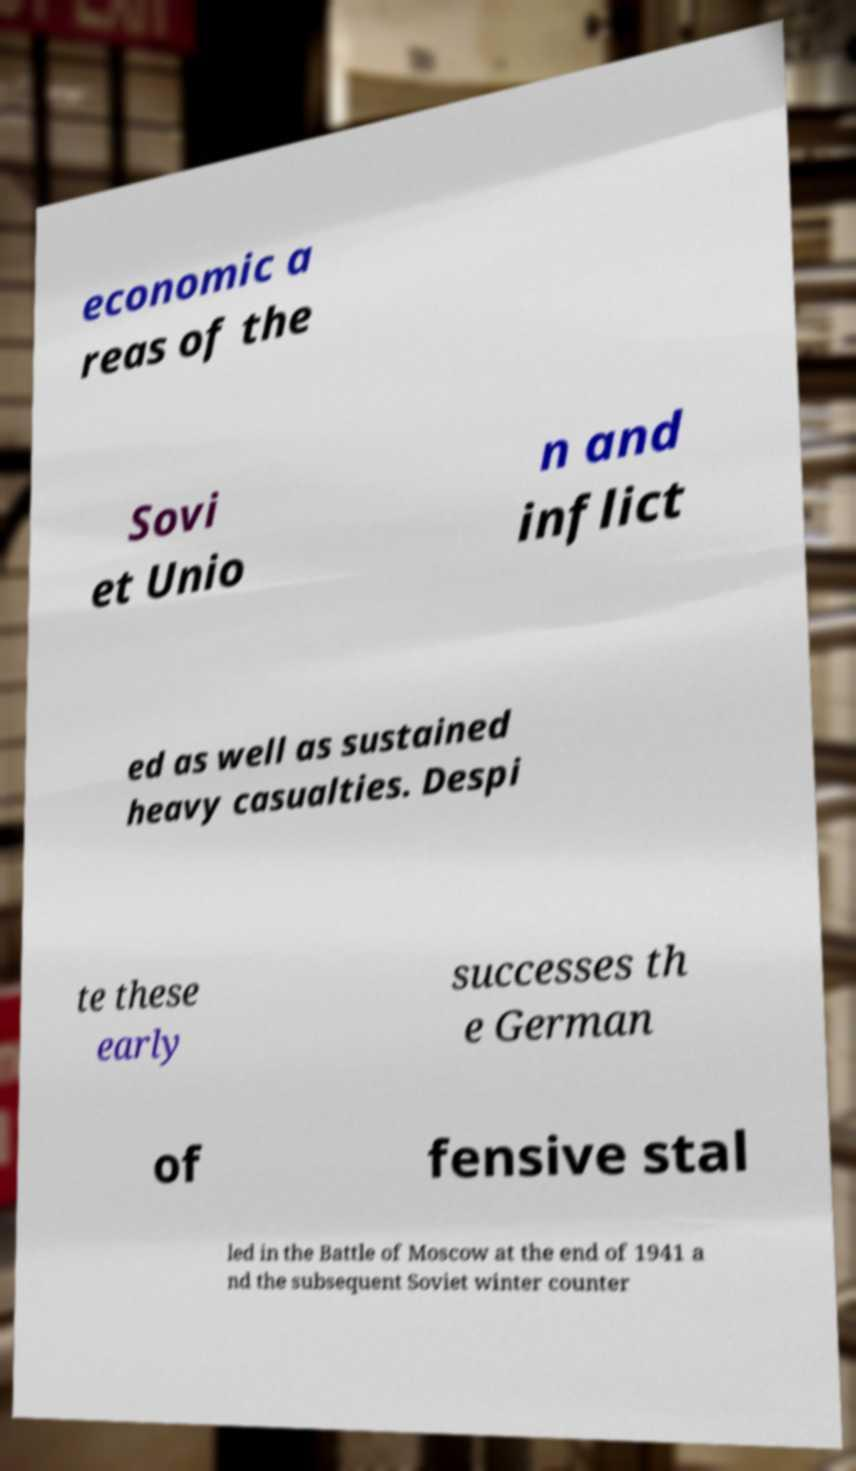Please read and relay the text visible in this image. What does it say? economic a reas of the Sovi et Unio n and inflict ed as well as sustained heavy casualties. Despi te these early successes th e German of fensive stal led in the Battle of Moscow at the end of 1941 a nd the subsequent Soviet winter counter 